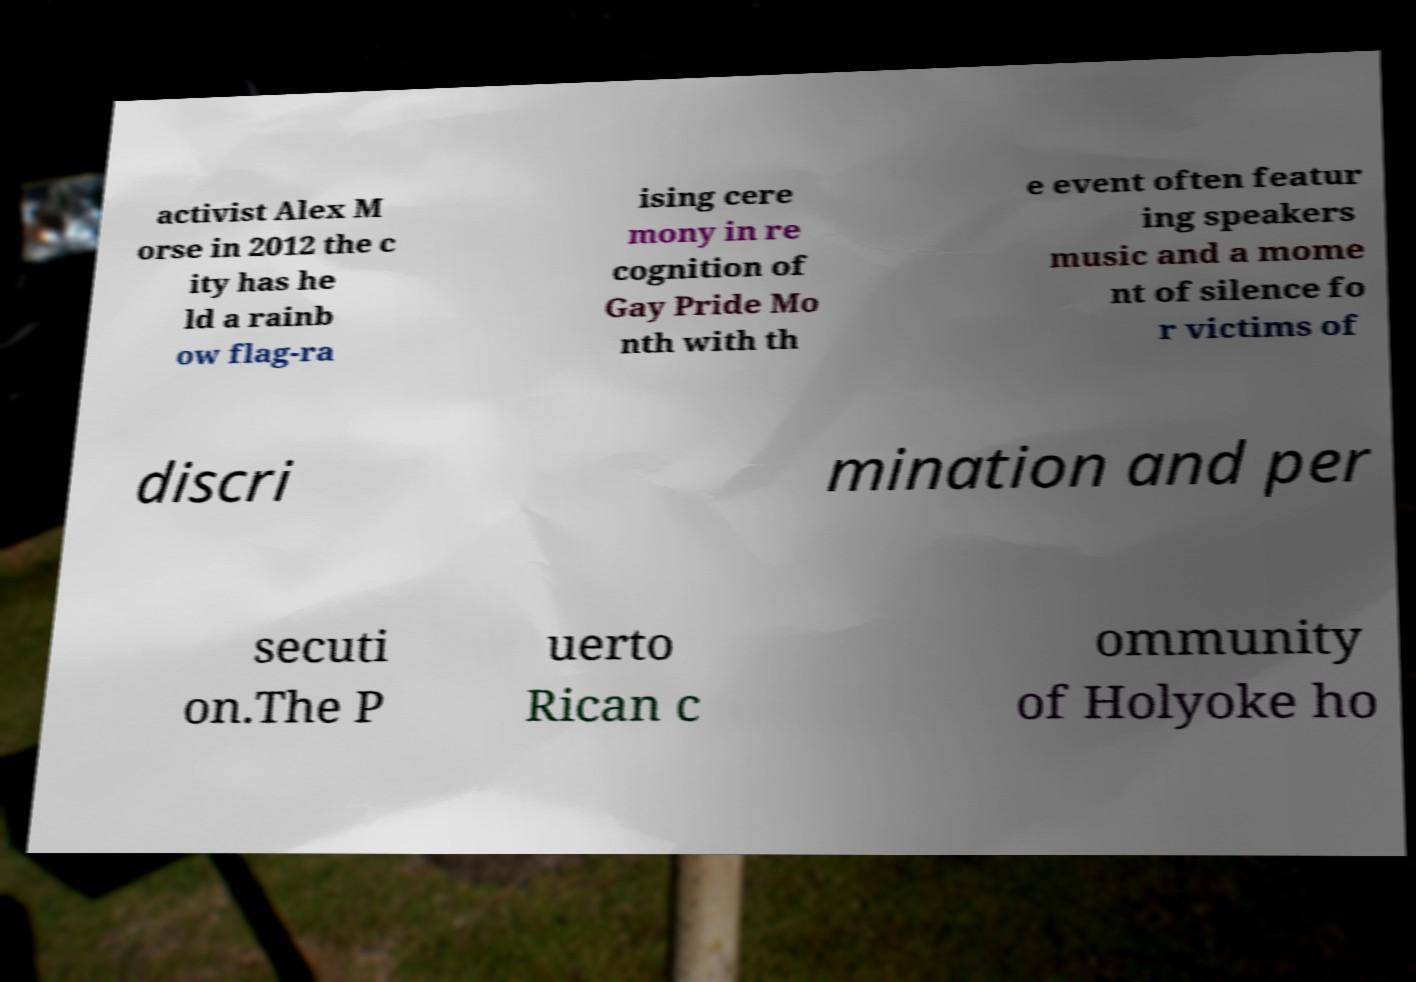There's text embedded in this image that I need extracted. Can you transcribe it verbatim? activist Alex M orse in 2012 the c ity has he ld a rainb ow flag-ra ising cere mony in re cognition of Gay Pride Mo nth with th e event often featur ing speakers music and a mome nt of silence fo r victims of discri mination and per secuti on.The P uerto Rican c ommunity of Holyoke ho 